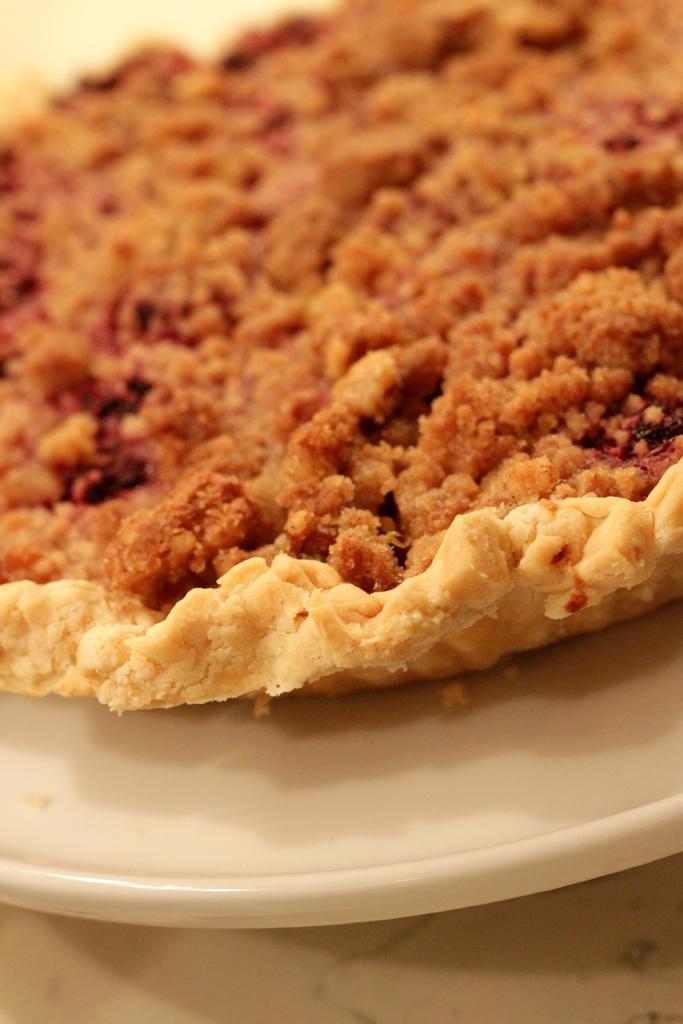Please provide a concise description of this image. In this image I can see a food item on the white color plate. Food is in brown and cream color. 